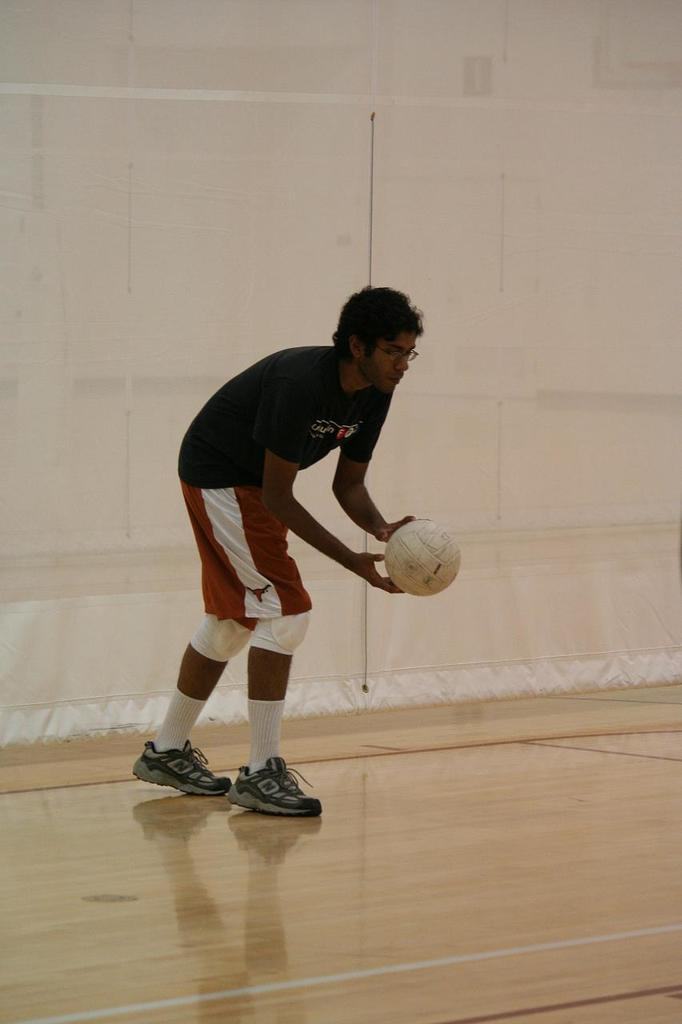What is the main subject of the image? There is a man standing in the image. Can you describe the man's attire? The man is wearing clothes, socks, and shoes. He is also wearing spectacles. What is the man holding in his hand? The man is holding a ball in his hand. What type of flooring is visible in the image? There is a wooden floor in the image. What is the background of the image? There is a wall in the image. What type of quill is the man using to write on the wooden floor in the image? There is no quill or writing activity present in the image. The man is holding a ball, and there is no indication that he is using a quill or writing on the wooden floor. 